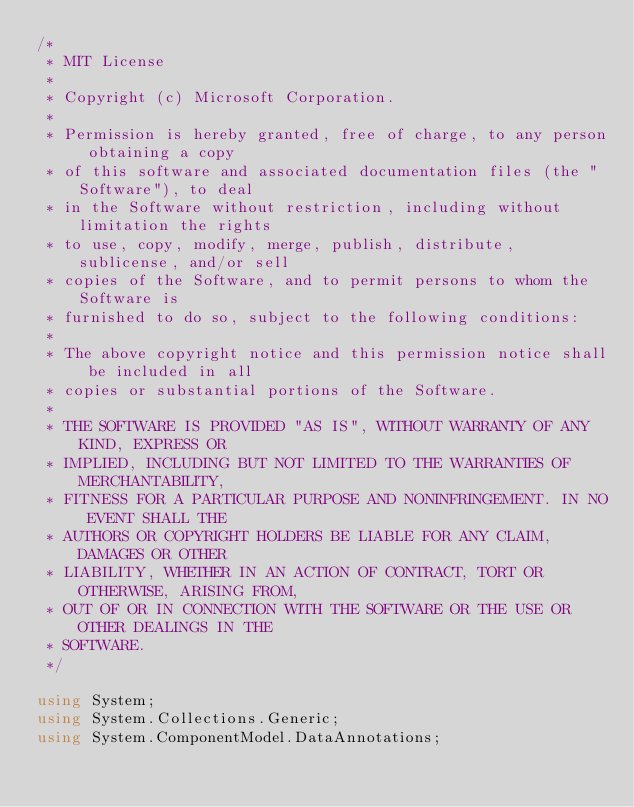Convert code to text. <code><loc_0><loc_0><loc_500><loc_500><_C#_>/*
 * MIT License
 *
 * Copyright (c) Microsoft Corporation.
 *
 * Permission is hereby granted, free of charge, to any person obtaining a copy
 * of this software and associated documentation files (the "Software"), to deal
 * in the Software without restriction, including without limitation the rights
 * to use, copy, modify, merge, publish, distribute, sublicense, and/or sell
 * copies of the Software, and to permit persons to whom the Software is
 * furnished to do so, subject to the following conditions:
 *
 * The above copyright notice and this permission notice shall be included in all
 * copies or substantial portions of the Software.
 *
 * THE SOFTWARE IS PROVIDED "AS IS", WITHOUT WARRANTY OF ANY KIND, EXPRESS OR
 * IMPLIED, INCLUDING BUT NOT LIMITED TO THE WARRANTIES OF MERCHANTABILITY,
 * FITNESS FOR A PARTICULAR PURPOSE AND NONINFRINGEMENT. IN NO EVENT SHALL THE
 * AUTHORS OR COPYRIGHT HOLDERS BE LIABLE FOR ANY CLAIM, DAMAGES OR OTHER
 * LIABILITY, WHETHER IN AN ACTION OF CONTRACT, TORT OR OTHERWISE, ARISING FROM,
 * OUT OF OR IN CONNECTION WITH THE SOFTWARE OR THE USE OR OTHER DEALINGS IN THE
 * SOFTWARE.
 */

using System;
using System.Collections.Generic;
using System.ComponentModel.DataAnnotations;</code> 